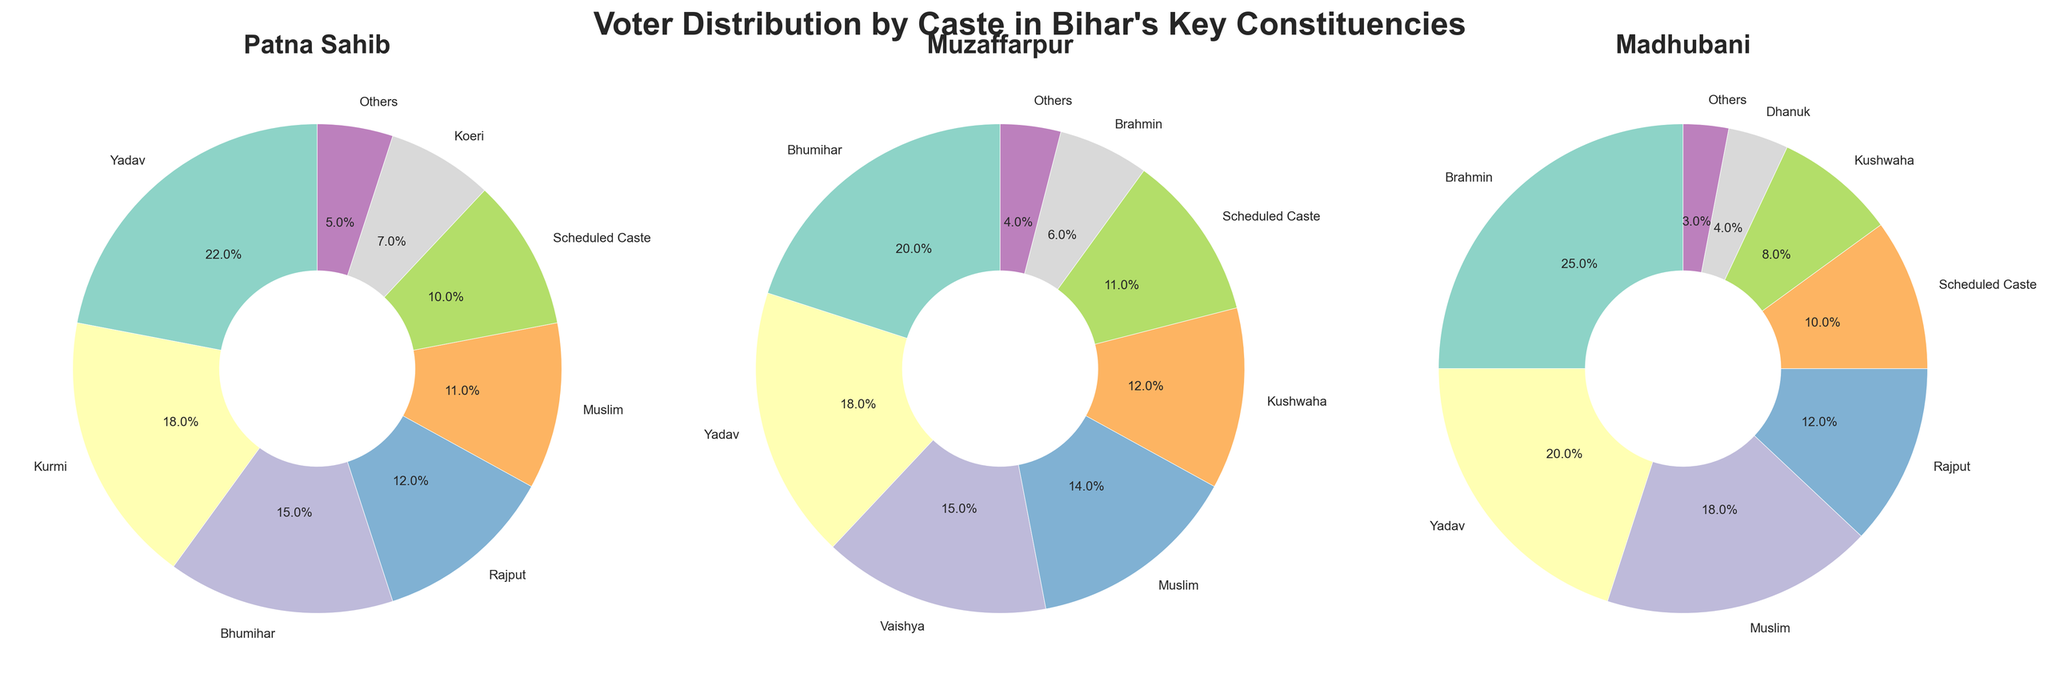What percentage of voters in Patna Sahib belong to the Yadav and Bhumihar castes combined? Add the percentages of Yadav (22%) and Bhumihar (15%) from the Patna Sahib pie chart. 22% + 15% = 37%
Answer: 37% Which caste has the smallest voter percentage in Muzaffarpur? Look at the Muzaffarpur pie chart and identify the caste with the lowest percentage. The "Others" category has the lowest with 4%.
Answer: Others How does the percentage of Muslim voters in Madhubani compare to Patna Sahib? Compare the percentage of Muslim voters in Madhubani (18%) with that in Patna Sahib (11%). 18% > 11%.
Answer: Higher in Madhubani Which constituency has the highest percentage of Brahmin voters? Compare the Brahmin voter percentages in all three constituencies. Madhubani has the highest with 25%.
Answer: Madhubani What is the difference in the Scheduled Caste voter percentage between Muzaffarpur and Madhubani? Subtract the Scheduled Caste percentage in Madhubani (10%) from that in Muzaffarpur (11%). 11% - 10% = 1%
Answer: 1% How are the voter distributions different for Yadavs in Patna Sahib and Muzaffarpur? Compare the Yadav voter percentages in Patna Sahib (22%) and Muzaffarpur (18%). Both values are close but higher in Patna Sahib.
Answer: Higher in Patna Sahib What is the sum of the Minor castes (Koeri, Others) percentage in Patna Sahib? Add the percentages of Koeri (7%) and Others (5%) from the Patna Sahib pie chart. 7% + 5% = 12%
Answer: 12% Describe the visual difference in the size of the "Muslim" shares of the pie charts for the three constituencies. Identify each slice labeled as "Muslim" in all three pie charts. Madhubani (18%) has a larger slice compared to Muzaffarpur (14%) and Patna Sahib (11%).
Answer: Largest in Madhubani Which caste forms the largest proportion of the electorate in Muzaffarpur? Identify the largest slice in Muzaffarpur pie chart. Bhumihar has the largest proportion with 20%.
Answer: Bhumihar What are the top three voter castes in Madhubani by percentage? Identify the three largest slices in Madhubani pie chart. Brahmin (25%), Yadav (20%), and Muslim (18%).
Answer: Brahmin, Yadav, Muslim 